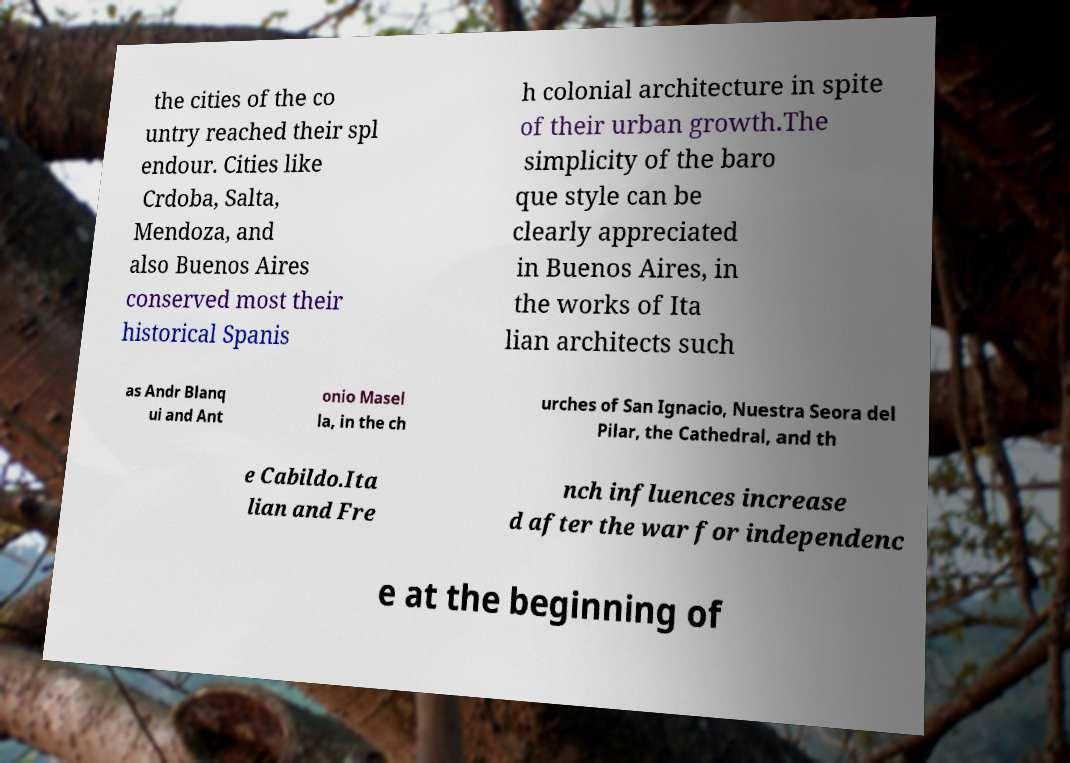What messages or text are displayed in this image? I need them in a readable, typed format. the cities of the co untry reached their spl endour. Cities like Crdoba, Salta, Mendoza, and also Buenos Aires conserved most their historical Spanis h colonial architecture in spite of their urban growth.The simplicity of the baro que style can be clearly appreciated in Buenos Aires, in the works of Ita lian architects such as Andr Blanq ui and Ant onio Masel la, in the ch urches of San Ignacio, Nuestra Seora del Pilar, the Cathedral, and th e Cabildo.Ita lian and Fre nch influences increase d after the war for independenc e at the beginning of 